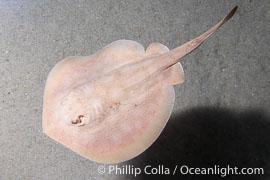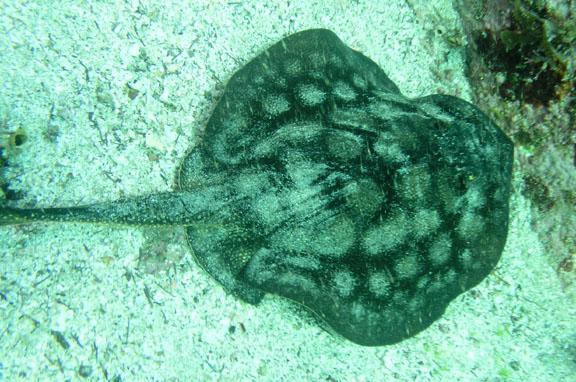The first image is the image on the left, the second image is the image on the right. Given the left and right images, does the statement "In the left image, there's a single round stingray facing the lower right." hold true? Answer yes or no. No. The first image is the image on the left, the second image is the image on the right. Examine the images to the left and right. Is the description "In at least one image a stingray's spine points to the 10:00 position." accurate? Answer yes or no. No. 